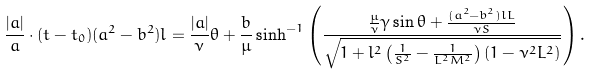Convert formula to latex. <formula><loc_0><loc_0><loc_500><loc_500>\frac { | a | } { a } \cdot ( t - t _ { 0 } ) ( a ^ { 2 } - b ^ { 2 } ) l = \frac { | a | } { \nu } \theta + \frac { b } { \mu } \sinh ^ { - 1 } { \left ( \frac { \frac { \mu } { \nu } \gamma \sin { \theta } + \frac { ( a ^ { 2 } - b ^ { 2 } ) l L } { \nu S } } { \sqrt { 1 + l ^ { 2 } \left ( \frac { 1 } { S ^ { 2 } } - \frac { 1 } { L ^ { 2 } M ^ { 2 } } \right ) ( 1 - \nu ^ { 2 } L ^ { 2 } ) } } \right ) . }</formula> 